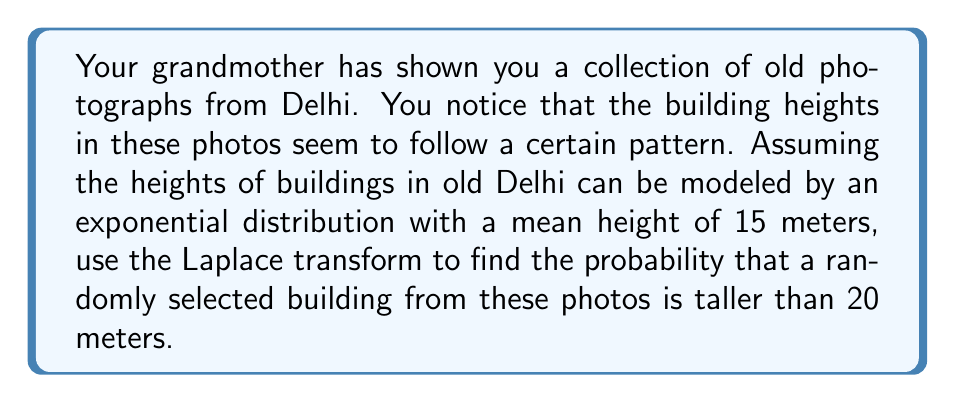What is the answer to this math problem? Let's approach this step-by-step using the Laplace transform:

1) The probability density function (PDF) of an exponential distribution is:

   $$f(x) = \lambda e^{-\lambda x}, \quad x \geq 0$$

   where $\lambda$ is the rate parameter.

2) Given that the mean height is 15 meters, we can find $\lambda$:

   $$E[X] = \frac{1}{\lambda} = 15 \quad \Rightarrow \quad \lambda = \frac{1}{15}$$

3) We want to find $P(X > 20)$, which is equivalent to:

   $$P(X > 20) = 1 - P(X \leq 20)$$

4) The cumulative distribution function (CDF) of an exponential distribution is:

   $$F(x) = 1 - e^{-\lambda x}$$

5) Therefore:

   $$P(X > 20) = 1 - (1 - e^{-\lambda 20}) = e^{-\lambda 20}$$

6) Now, let's use the Laplace transform. The Laplace transform of $e^{-ax}$ is:

   $$\mathcal{L}\{e^{-ax}\} = \frac{1}{s + a}$$

7) In our case, $a = \lambda = \frac{1}{15}$ and we're evaluating at $x = 20$. So we need to find:

   $$\mathcal{L}^{-1}\{\frac{1}{s + \frac{1}{15}}\}|_{x=20}$$

8) The inverse Laplace transform gives us back $e^{-\frac{x}{15}}$, which we evaluate at $x = 20$:

   $$e^{-\frac{20}{15}} = e^{-\frac{4}{3}} \approx 0.2636$$

Therefore, the probability that a randomly selected building from the old photos is taller than 20 meters is approximately 0.2636 or 26.36%.
Answer: $P(X > 20) = e^{-\frac{4}{3}} \approx 0.2636$ or 26.36% 